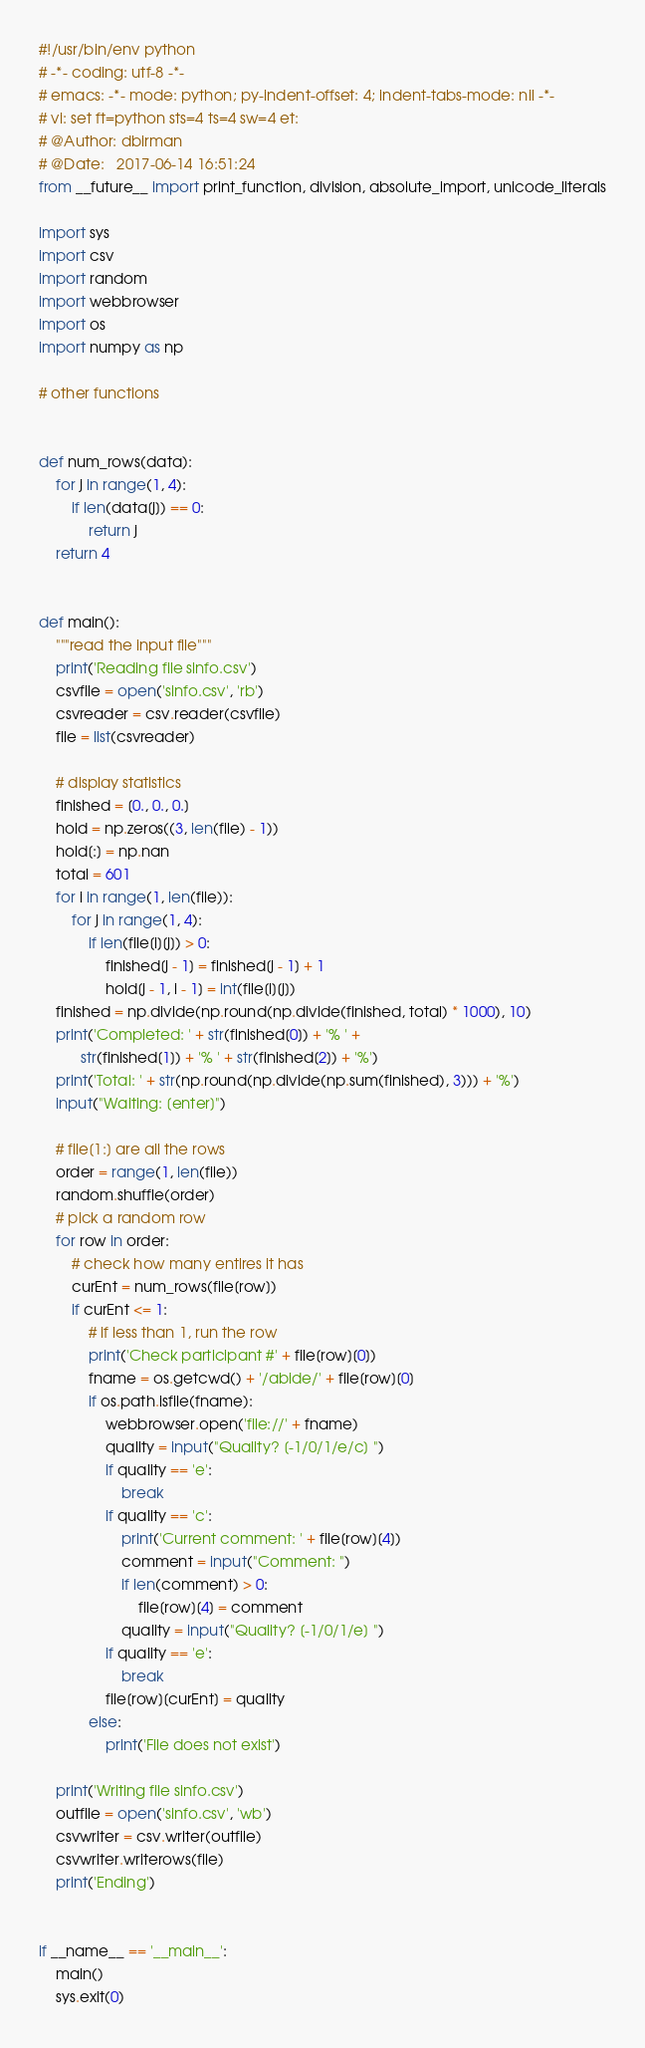<code> <loc_0><loc_0><loc_500><loc_500><_Python_>#!/usr/bin/env python
# -*- coding: utf-8 -*-
# emacs: -*- mode: python; py-indent-offset: 4; indent-tabs-mode: nil -*-
# vi: set ft=python sts=4 ts=4 sw=4 et:
# @Author: dbirman
# @Date:   2017-06-14 16:51:24
from __future__ import print_function, division, absolute_import, unicode_literals

import sys
import csv
import random
import webbrowser
import os
import numpy as np

# other functions


def num_rows(data):
    for j in range(1, 4):
        if len(data[j]) == 0:
            return j
    return 4


def main():
    """read the input file"""
    print('Reading file sinfo.csv')
    csvfile = open('sinfo.csv', 'rb')
    csvreader = csv.reader(csvfile)
    file = list(csvreader)

    # display statistics
    finished = [0., 0., 0.]
    hold = np.zeros((3, len(file) - 1))
    hold[:] = np.nan
    total = 601
    for i in range(1, len(file)):
        for j in range(1, 4):
            if len(file[i][j]) > 0:
                finished[j - 1] = finished[j - 1] + 1
                hold[j - 1, i - 1] = int(file[i][j])
    finished = np.divide(np.round(np.divide(finished, total) * 1000), 10)
    print('Completed: ' + str(finished[0]) + '% ' +
          str(finished[1]) + '% ' + str(finished[2]) + '%')
    print('Total: ' + str(np.round(np.divide(np.sum(finished), 3))) + '%')
    input("Waiting: [enter]")

    # file[1:] are all the rows
    order = range(1, len(file))
    random.shuffle(order)
    # pick a random row
    for row in order:
        # check how many entires it has
        curEnt = num_rows(file[row])
        if curEnt <= 1:
            # if less than 1, run the row
            print('Check participant #' + file[row][0])
            fname = os.getcwd() + '/abide/' + file[row][0]
            if os.path.isfile(fname):
                webbrowser.open('file://' + fname)
                quality = input("Quality? [-1/0/1/e/c] ")
                if quality == 'e':
                    break
                if quality == 'c':
                    print('Current comment: ' + file[row][4])
                    comment = input("Comment: ")
                    if len(comment) > 0:
                        file[row][4] = comment
                    quality = input("Quality? [-1/0/1/e] ")
                if quality == 'e':
                    break
                file[row][curEnt] = quality
            else:
                print('File does not exist')

    print('Writing file sinfo.csv')
    outfile = open('sinfo.csv', 'wb')
    csvwriter = csv.writer(outfile)
    csvwriter.writerows(file)
    print('Ending')


if __name__ == '__main__':
    main()
    sys.exit(0)
</code> 